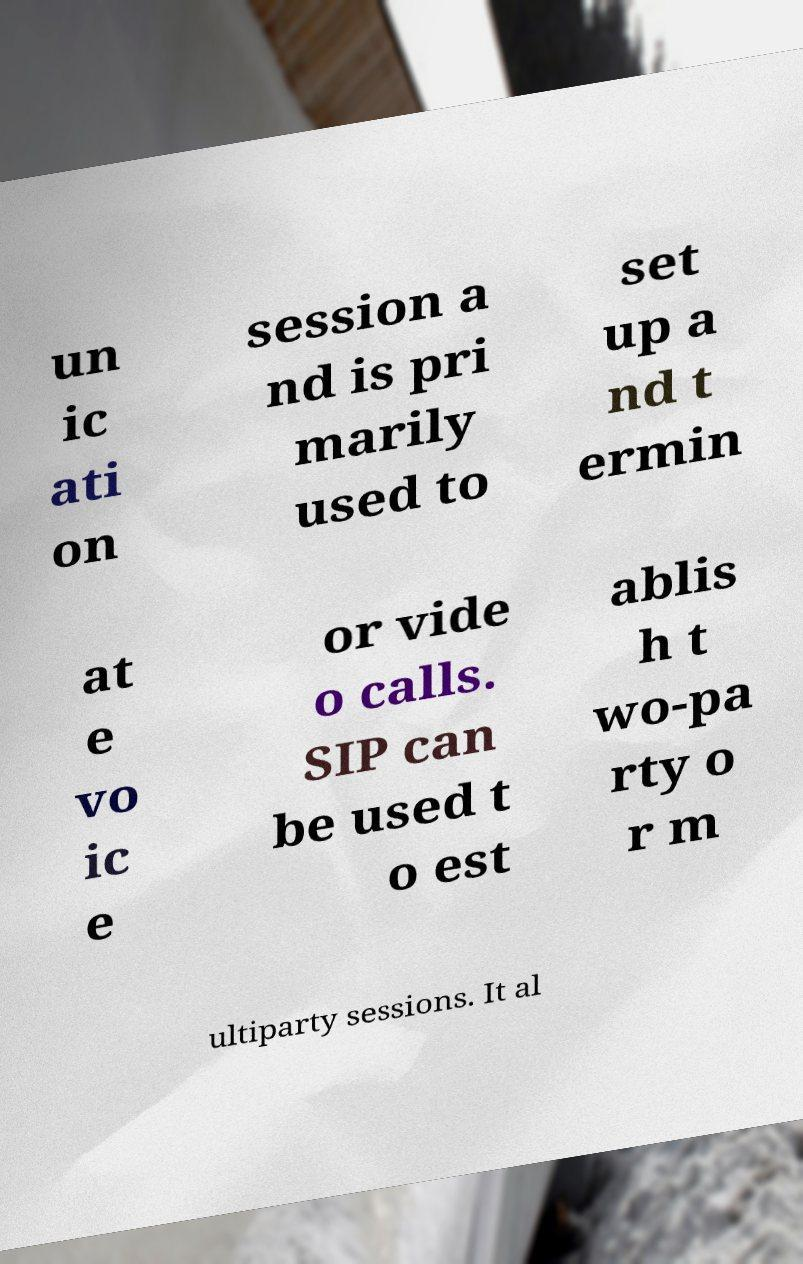I need the written content from this picture converted into text. Can you do that? un ic ati on session a nd is pri marily used to set up a nd t ermin at e vo ic e or vide o calls. SIP can be used t o est ablis h t wo-pa rty o r m ultiparty sessions. It al 